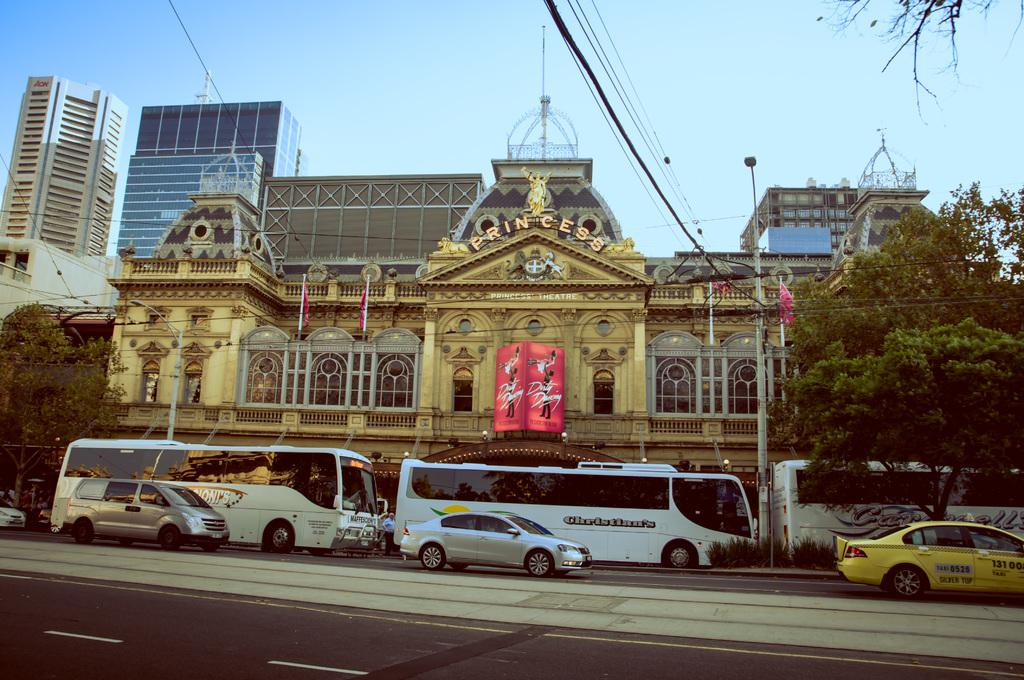<image>
Relay a brief, clear account of the picture shown. Large tour buses are stopped in front of the princess theater. 